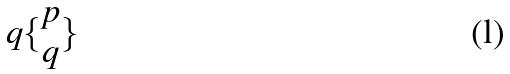<formula> <loc_0><loc_0><loc_500><loc_500>q \{ \begin{matrix} p \\ q \end{matrix} \}</formula> 